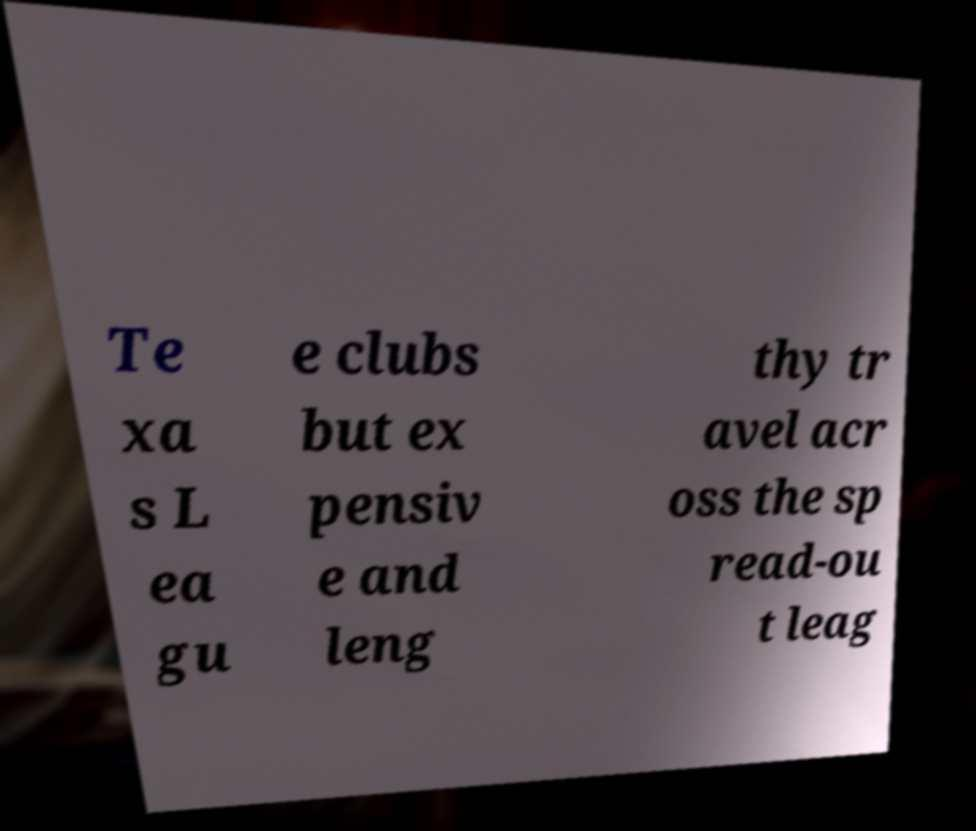Could you assist in decoding the text presented in this image and type it out clearly? Te xa s L ea gu e clubs but ex pensiv e and leng thy tr avel acr oss the sp read-ou t leag 